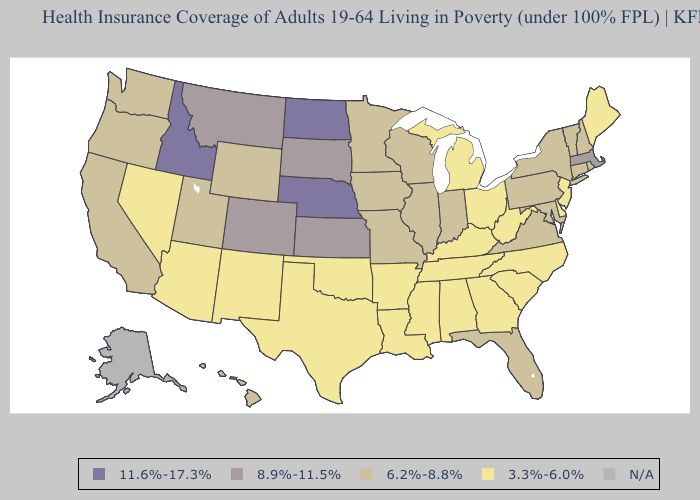Name the states that have a value in the range 8.9%-11.5%?
Quick response, please. Colorado, Kansas, Massachusetts, Montana, South Dakota. Which states hav the highest value in the Northeast?
Answer briefly. Massachusetts. Among the states that border Oregon , which have the lowest value?
Answer briefly. Nevada. Name the states that have a value in the range 11.6%-17.3%?
Quick response, please. Idaho, Nebraska, North Dakota. Among the states that border Oregon , does California have the highest value?
Keep it brief. No. Does Maryland have the highest value in the USA?
Answer briefly. No. Does Pennsylvania have the highest value in the USA?
Short answer required. No. Name the states that have a value in the range 8.9%-11.5%?
Answer briefly. Colorado, Kansas, Massachusetts, Montana, South Dakota. Name the states that have a value in the range 11.6%-17.3%?
Write a very short answer. Idaho, Nebraska, North Dakota. What is the value of Pennsylvania?
Quick response, please. 6.2%-8.8%. Which states hav the highest value in the Northeast?
Short answer required. Massachusetts. Which states have the lowest value in the USA?
Quick response, please. Alabama, Arizona, Arkansas, Delaware, Georgia, Kentucky, Louisiana, Maine, Michigan, Mississippi, Nevada, New Jersey, New Mexico, North Carolina, Ohio, Oklahoma, South Carolina, Tennessee, Texas, West Virginia. Among the states that border Pennsylvania , which have the lowest value?
Concise answer only. Delaware, New Jersey, Ohio, West Virginia. What is the lowest value in states that border North Dakota?
Short answer required. 6.2%-8.8%. 